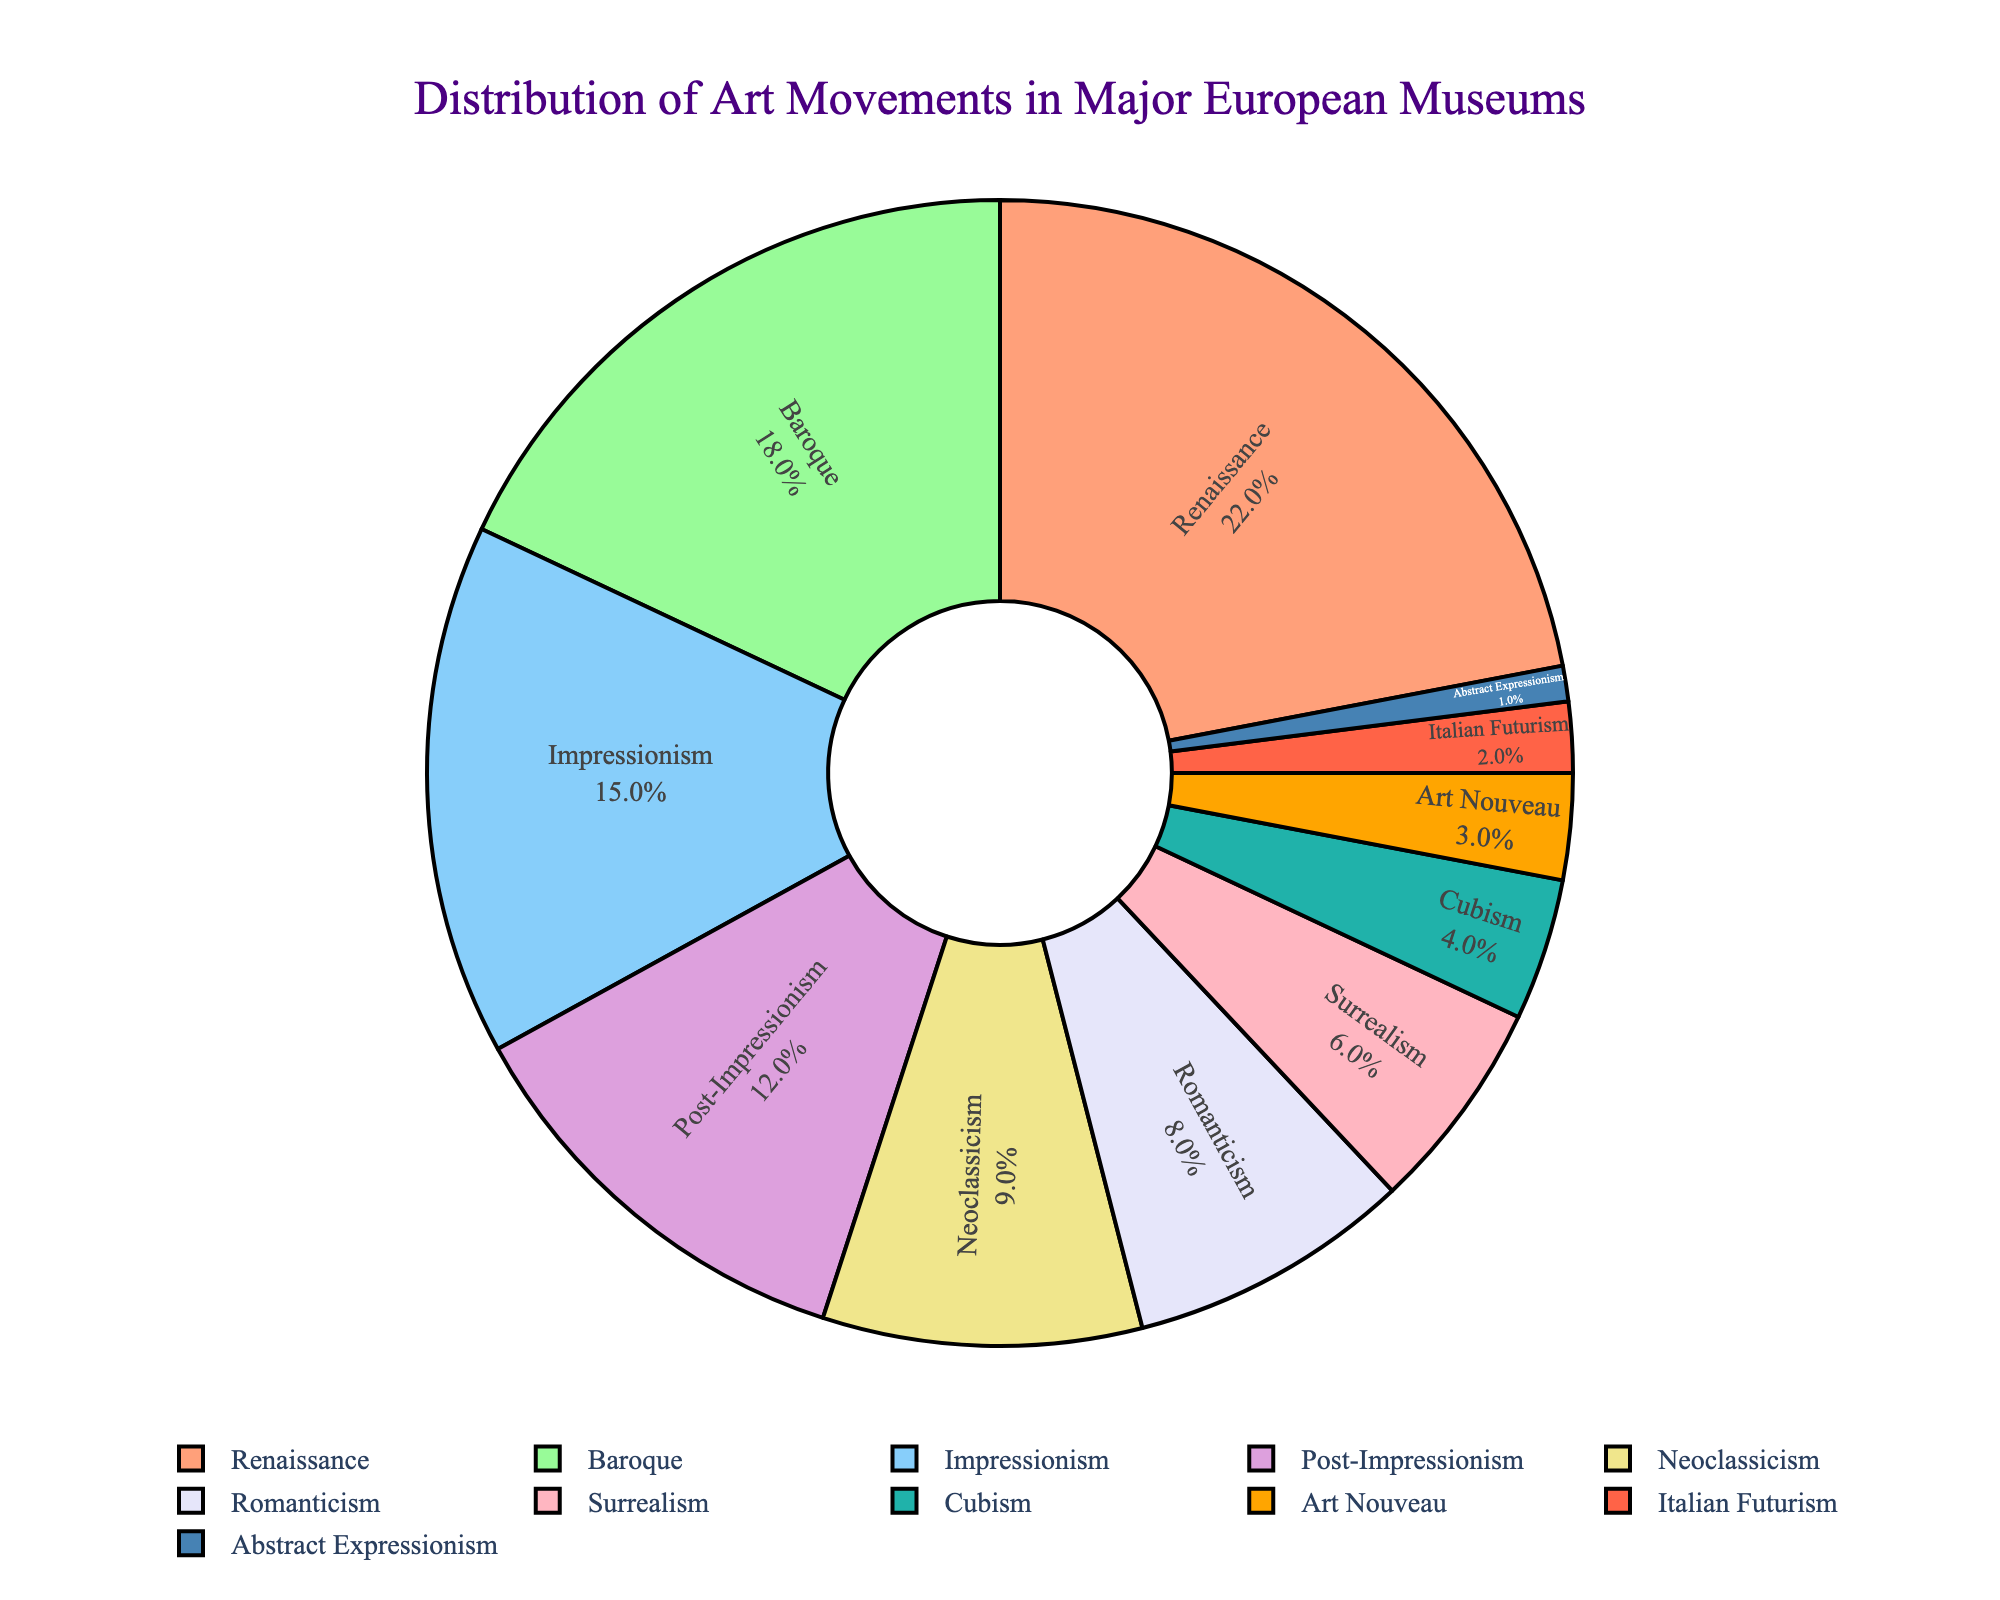What is the second most represented art movement in major European museums? To find the second most represented art movement, we look for the movement with the second-highest percentage. From the chart, after Renaissance (22%), Baroque comes next with 18%.
Answer: Baroque What is the total percentage of Impressionist and Post-Impressionist artworks combined? Sum the percentages of Impressionism and Post-Impressionism: 15% (Impressionism) + 12% (Post-Impressionism) = 27%.
Answer: 27% Which art movement is represented the least in major European museums? Identify the movement with the smallest percentage. According to the chart, Abstract Expressionism is the least represented with just 1%.
Answer: Abstract Expressionism How many art movements have a percentage representation of 10% or higher? Count the number of movements with percentages 10% or higher: Renaissance (22%), Baroque (18%), Impressionism (15%), Post-Impressionism (12%). This adds up to 4 movements.
Answer: 4 Which movement has a larger share: Surrealism or Cubism? Compare the percentages of Surrealism (6%) and Cubism (4%). Since 6% is greater than 4%, Surrealism has a larger share.
Answer: Surrealism What is the combined percentage of movements that have less than 5% representation? Add the percentages of movements with less than 5%: Cubism (4%), Art Nouveau (3%), Italian Futurism (2%), Abstract Expressionism (1%). The combined percentage is 4% + 3% + 2% + 1% = 10%.
Answer: 10% Is the percentage of Romanticism greater or less than the percentage of Neoclassicism? Compare the percentages: Romanticism (8%) and Neoclassicism (9%). Since 8% is less than 9%, Romanticism has a smaller percentage.
Answer: Less Which segments on the pie chart are visually indicated with shades of purple? Look at the visual attributes (colors). The Renaissance (22%) and Cubism (4%) segments utilize shades of purple.
Answer: Renaissance and Cubism What is the difference in percentage between the Renaissance and Surrealism movements? Subtract the percentage of Surrealism from Renaissance: 22% (Renaissance) - 6% (Surrealism) = 16%.
Answer: 16% If we combine the percentages of Baroque, Romanticism, and Italian Futurism, what is their total representation? Sum the percentages of Baroque, Romanticism, and Italian Futurism: 18% (Baroque) + 8% (Romanticism) + 2% (Italian Futurism) = 28%.
Answer: 28% 